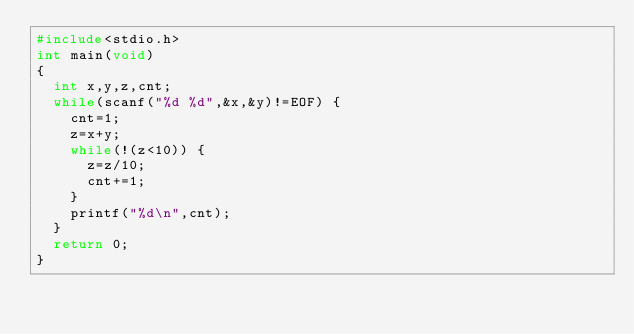Convert code to text. <code><loc_0><loc_0><loc_500><loc_500><_C_>#include<stdio.h>
int main(void)
{
	int x,y,z,cnt;
	while(scanf("%d %d",&x,&y)!=EOF) {
		cnt=1;
		z=x+y;
		while(!(z<10)) {
			z=z/10;
			cnt+=1;
		}
		printf("%d\n",cnt);
	}
	return 0;
}</code> 